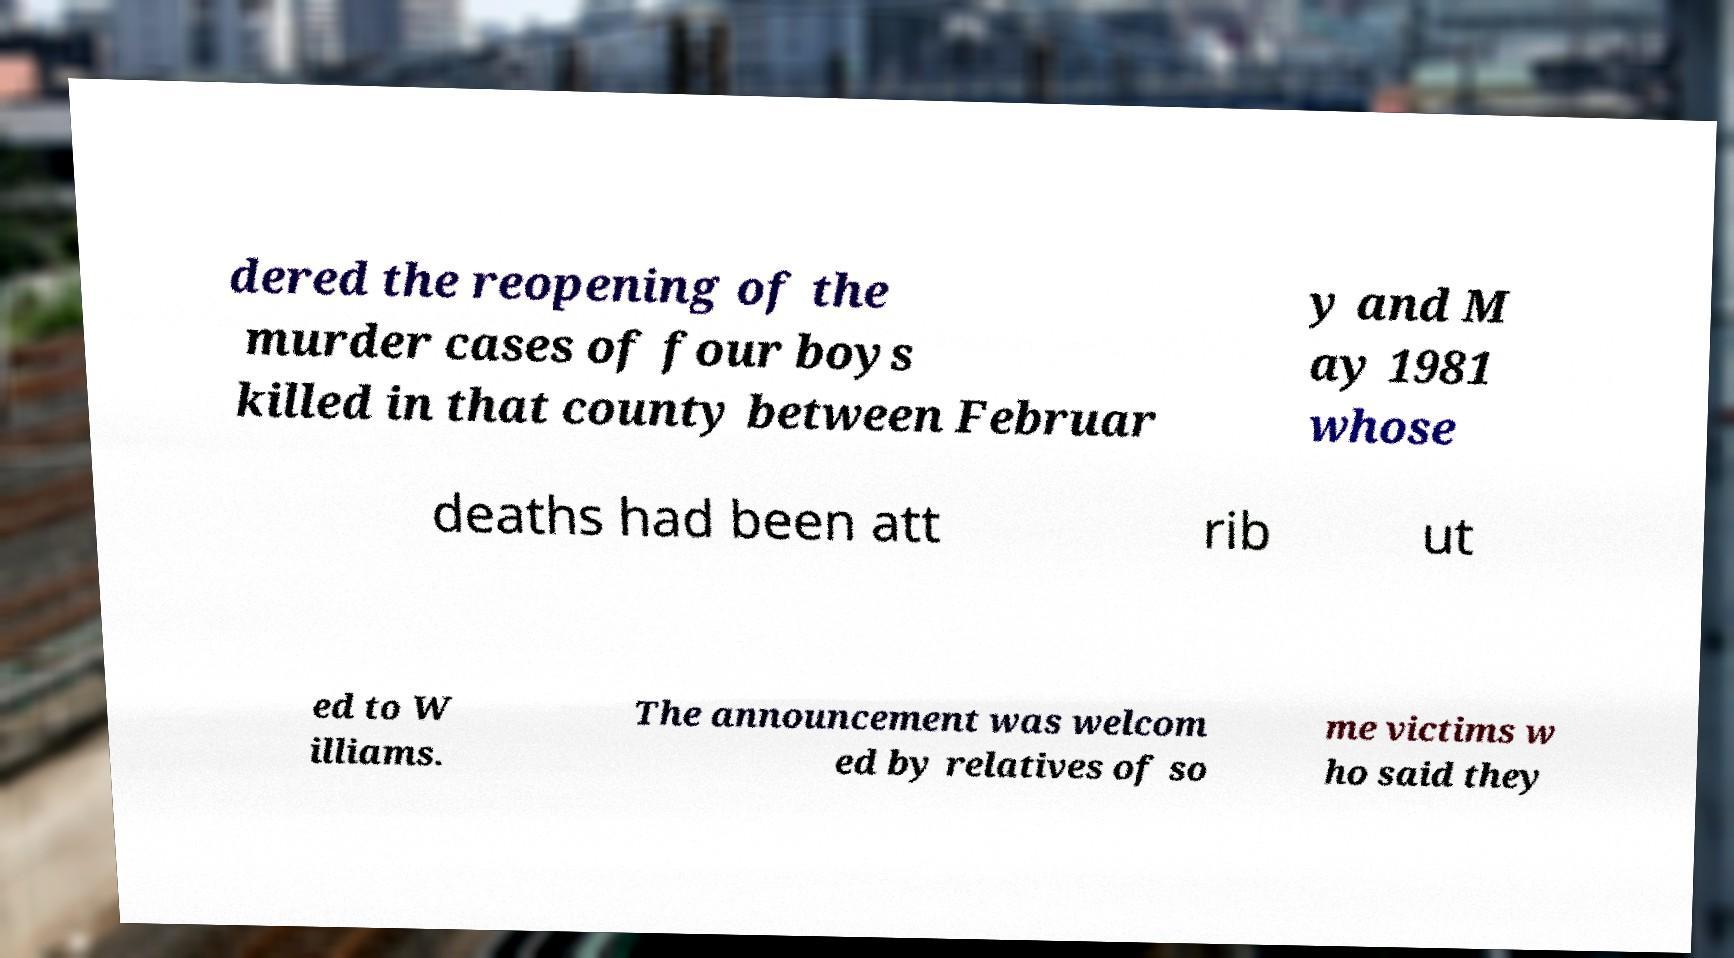Please read and relay the text visible in this image. What does it say? dered the reopening of the murder cases of four boys killed in that county between Februar y and M ay 1981 whose deaths had been att rib ut ed to W illiams. The announcement was welcom ed by relatives of so me victims w ho said they 